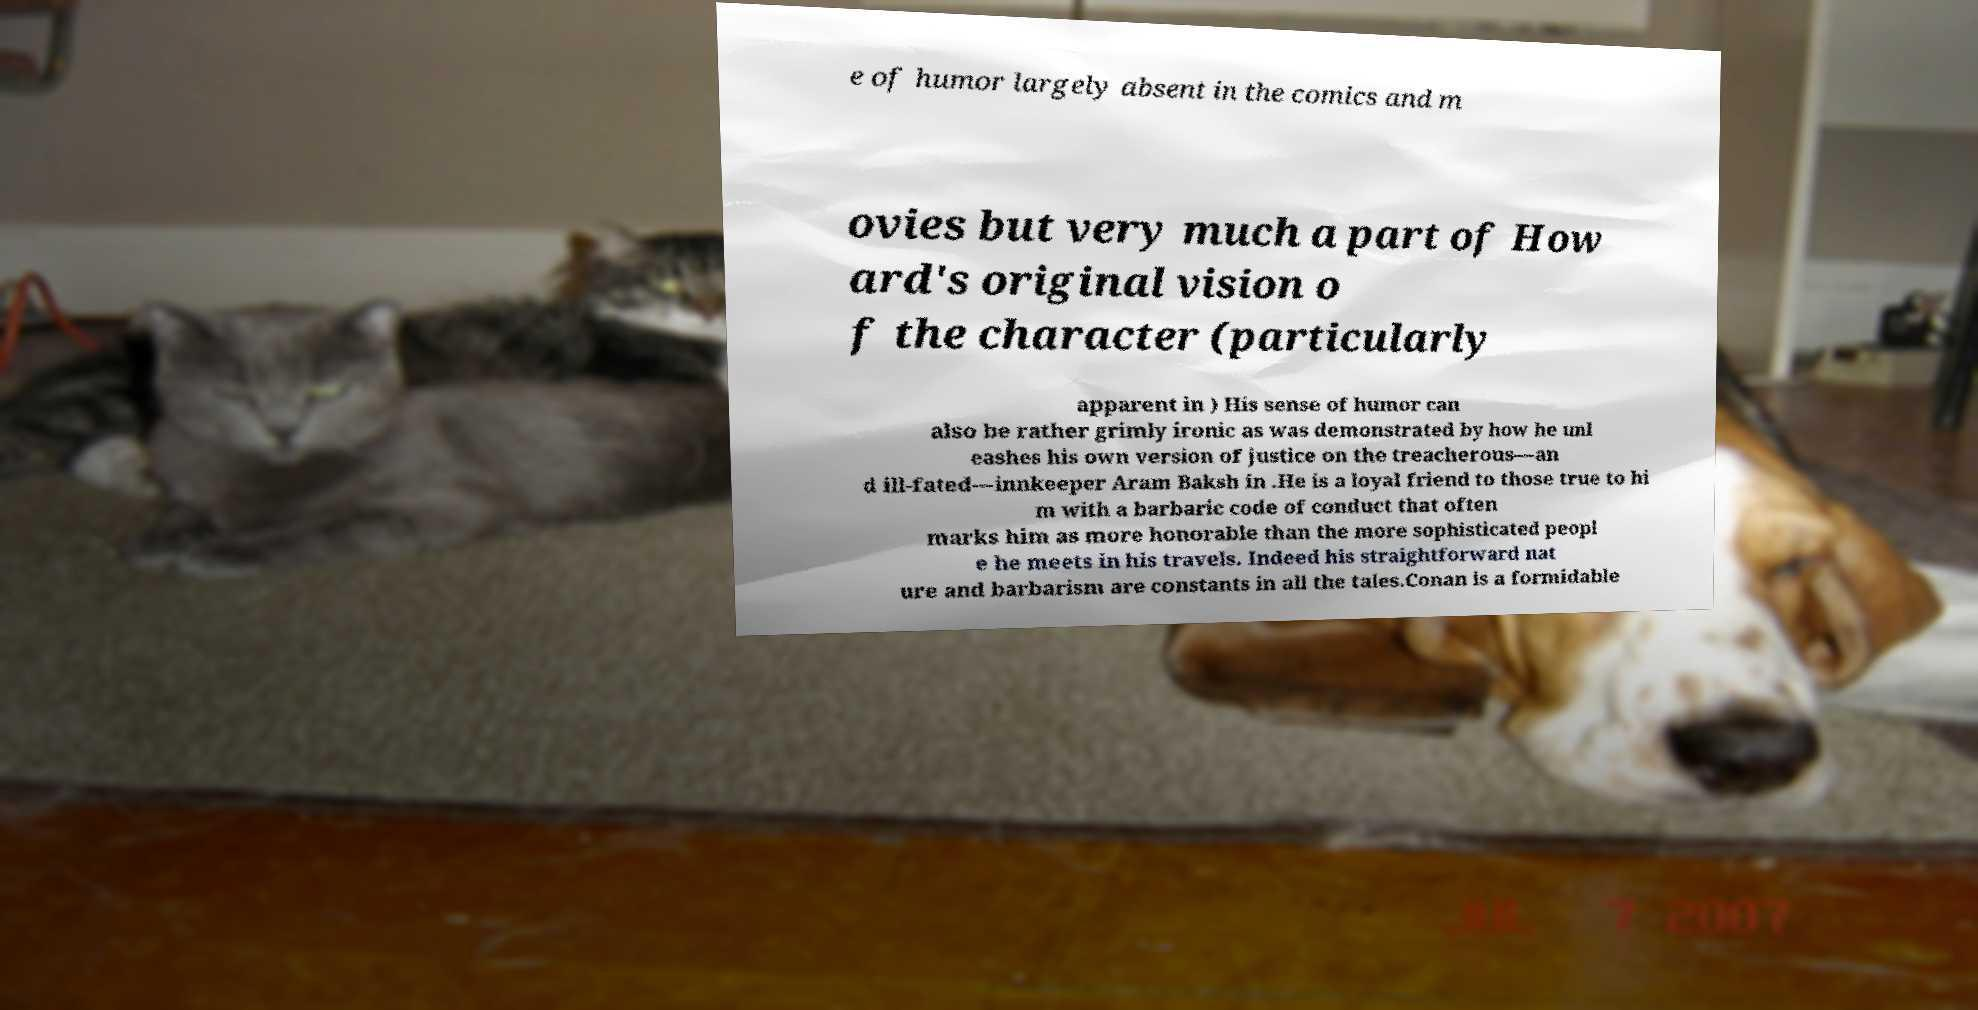What messages or text are displayed in this image? I need them in a readable, typed format. e of humor largely absent in the comics and m ovies but very much a part of How ard's original vision o f the character (particularly apparent in ) His sense of humor can also be rather grimly ironic as was demonstrated by how he unl eashes his own version of justice on the treacherous—an d ill-fated—innkeeper Aram Baksh in .He is a loyal friend to those true to hi m with a barbaric code of conduct that often marks him as more honorable than the more sophisticated peopl e he meets in his travels. Indeed his straightforward nat ure and barbarism are constants in all the tales.Conan is a formidable 